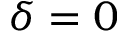Convert formula to latex. <formula><loc_0><loc_0><loc_500><loc_500>\delta = 0</formula> 